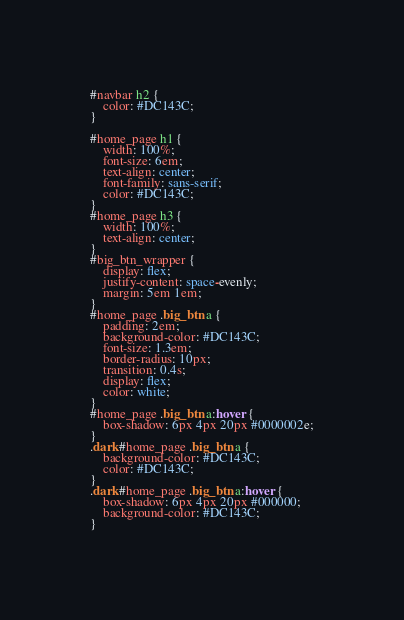<code> <loc_0><loc_0><loc_500><loc_500><_CSS_>
#navbar h2 {
    color: #DC143C;
}

#home_page h1 {
    width: 100%;
    font-size: 6em;
    text-align: center;
    font-family: sans-serif;
    color: #DC143C;
}
#home_page h3 {
    width: 100%;
    text-align: center;
}
#big_btn_wrapper {
    display: flex;
    justify-content: space-evenly;
    margin: 5em 1em;
}
#home_page .big_btn a {
    padding: 2em;
    background-color: #DC143C;
    font-size: 1.3em;
    border-radius: 10px;
    transition: 0.4s;
    display: flex;
    color: white;
}
#home_page .big_btn a:hover {
    box-shadow: 6px 4px 20px #0000002e;
}
.dark #home_page .big_btn a {
    background-color: #DC143C;
    color: #DC143C;
}
.dark #home_page .big_btn a:hover {
    box-shadow: 6px 4px 20px #000000;
    background-color: #DC143C;
}
</code> 